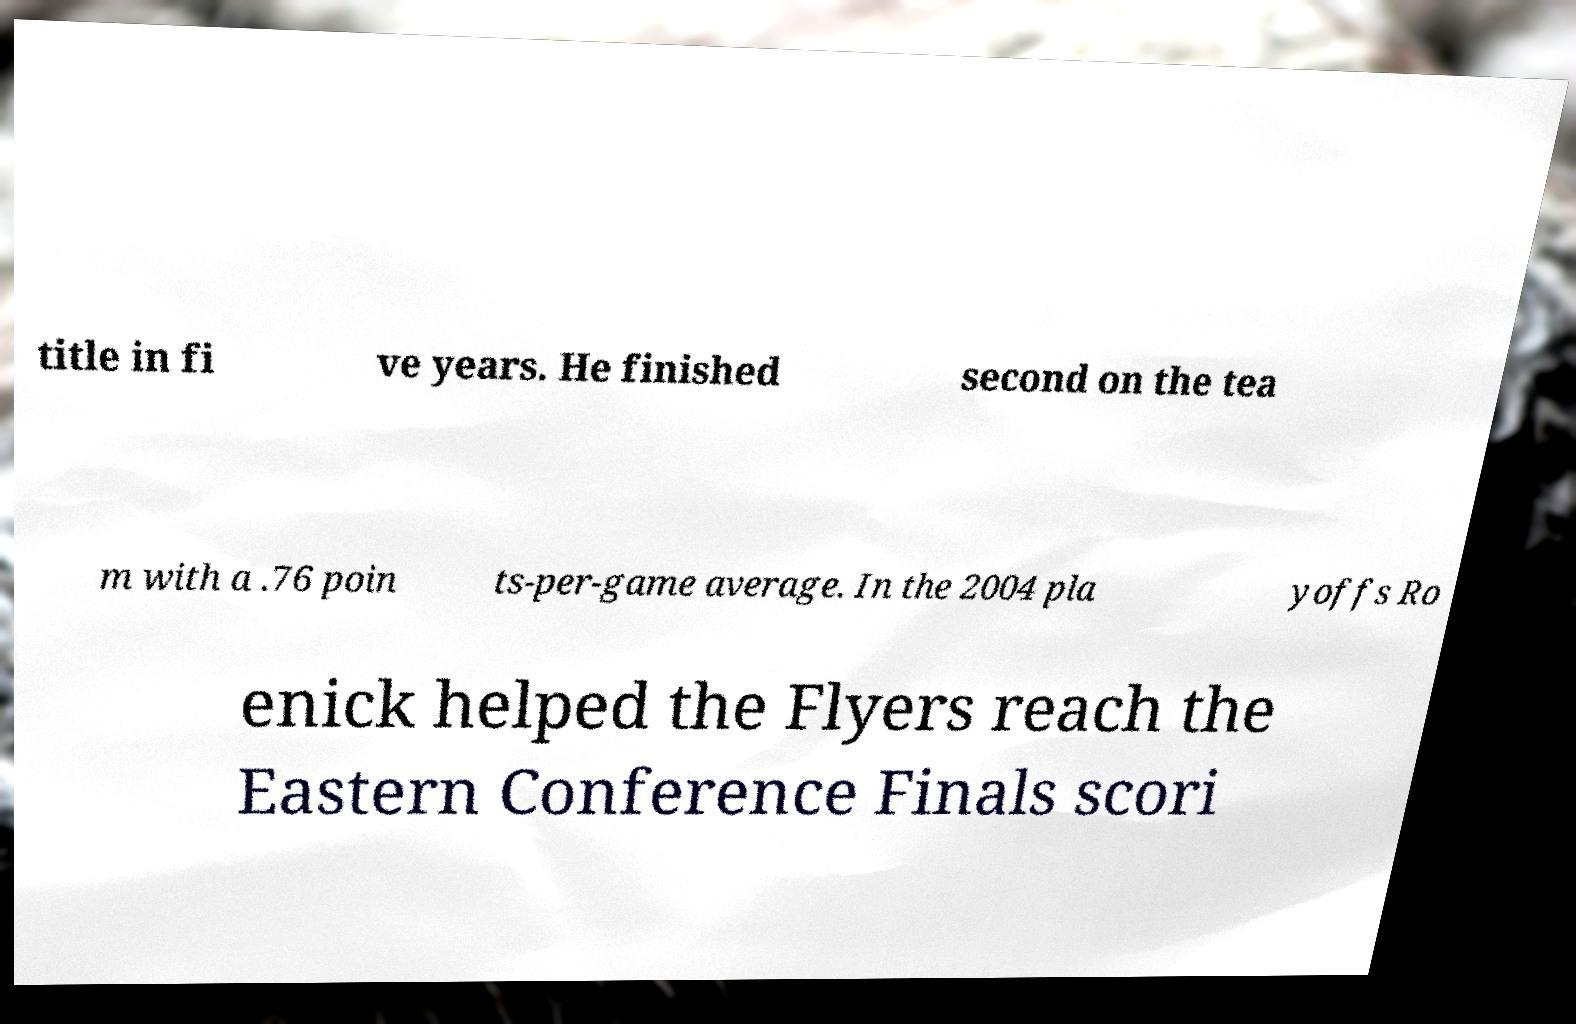Can you accurately transcribe the text from the provided image for me? title in fi ve years. He finished second on the tea m with a .76 poin ts-per-game average. In the 2004 pla yoffs Ro enick helped the Flyers reach the Eastern Conference Finals scori 